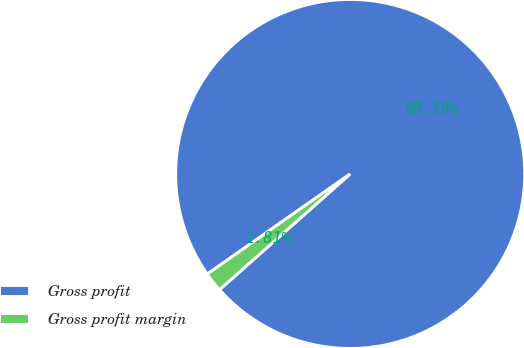Convert chart. <chart><loc_0><loc_0><loc_500><loc_500><pie_chart><fcel>Gross profit<fcel>Gross profit margin<nl><fcel>98.19%<fcel>1.81%<nl></chart> 